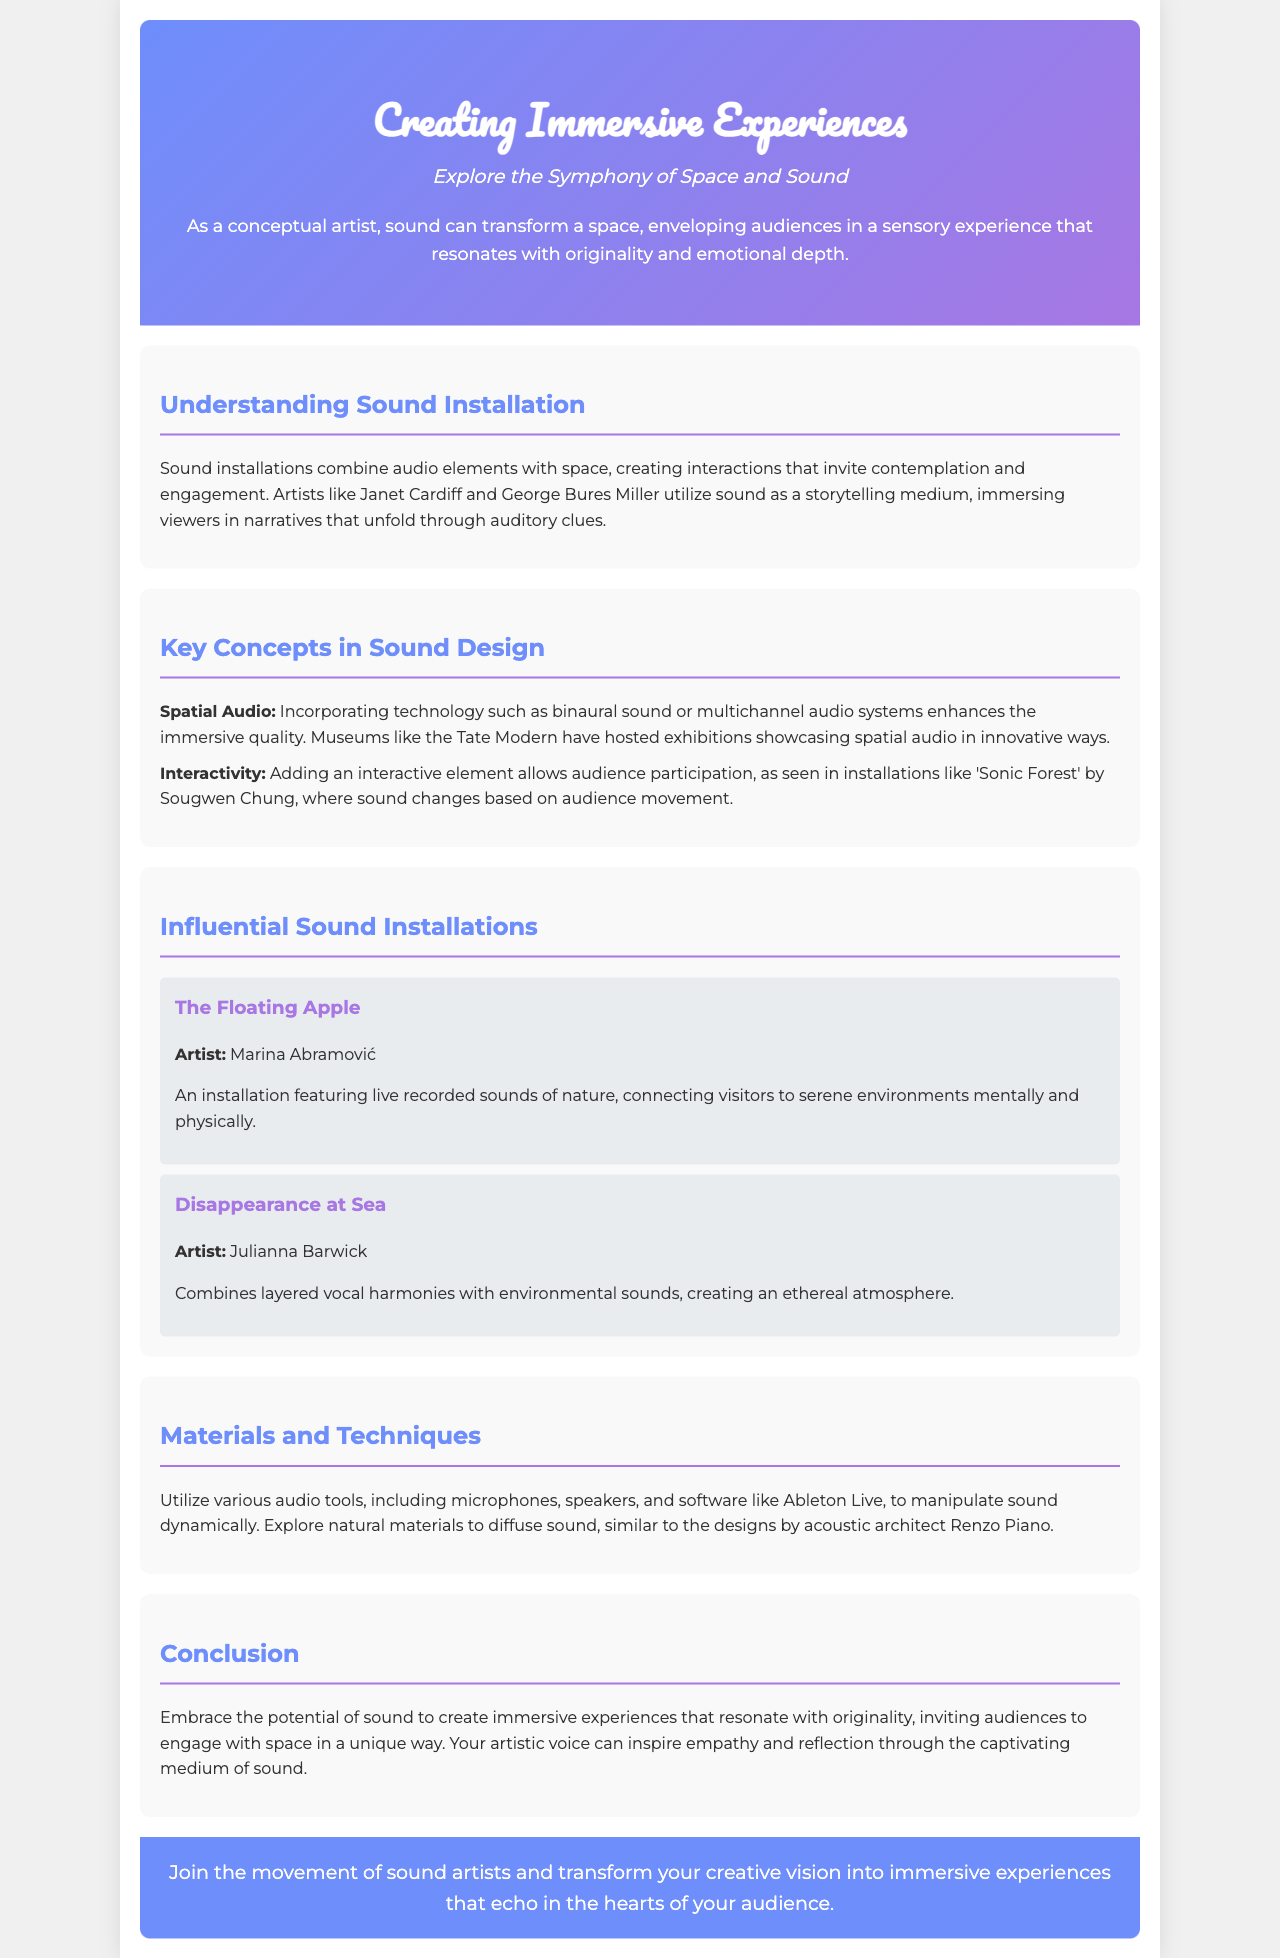What is the title of the brochure? The title is stated clearly at the top of the document, highlighting the main theme.
Answer: Creating Immersive Experiences: The Art of Sound Installation Design Who are the artists mentioned in the Influential Sound Installations section? The section lists specific artists alongside their respective installations.
Answer: Marina Abramović, Julianna Barwick What technology enhances the immersive quality in sound design? The document specifies a particular technology that is imperative for creating spatial audio experiences.
Answer: Binaural sound or multichannel audio systems What is the example installation by Sougwen Chung? The document gives an example of an interactive sound installation that involves audience participation.
Answer: Sonic Forest What is the main purpose of sound installations? The introduction explains the overall goal and impact of sound installations on the audience.
Answer: To create interactions that invite contemplation and engagement Which software is mentioned for manipulating sound dynamically? The text includes a specific software tool recommended for audio manipulation.
Answer: Ableton Live What is the concluding message of the brochure? The conclusion emphasizes a core idea about the potential impact of sound as an artistic medium.
Answer: Embrace the potential of sound to create immersive experiences How is the tag line presented in the brochure? The tagline is displayed just below the title and summarizes the brochure's theme creatively.
Answer: Explore the Symphony of Space and Sound 